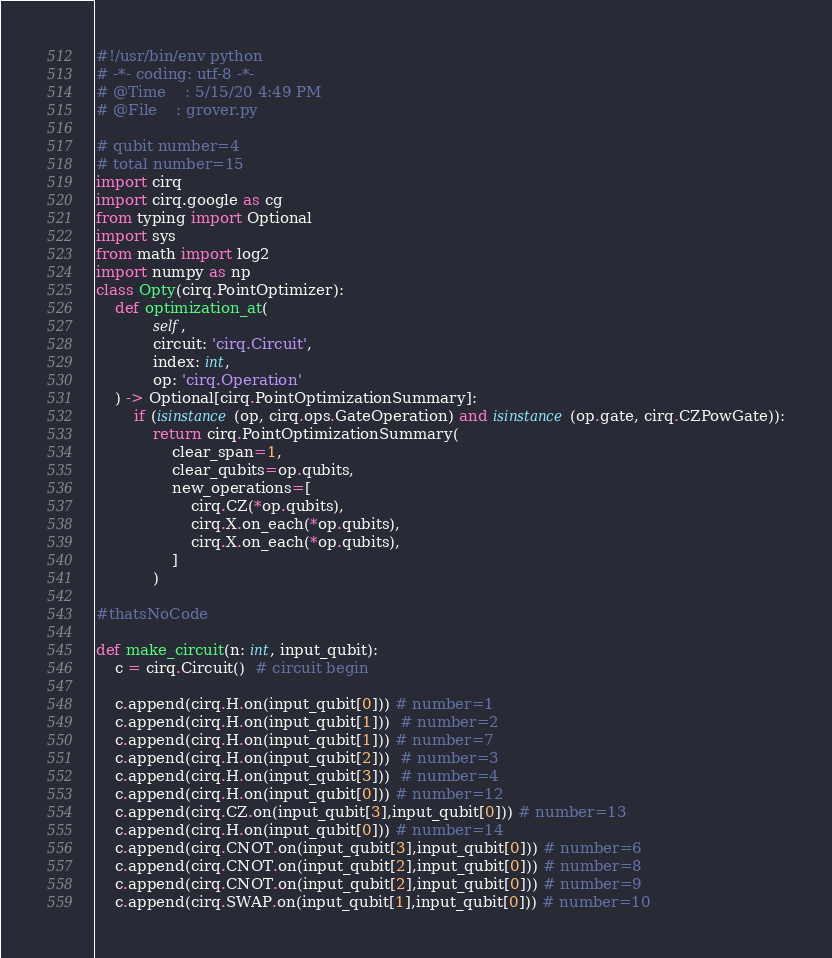Convert code to text. <code><loc_0><loc_0><loc_500><loc_500><_Python_>#!/usr/bin/env python
# -*- coding: utf-8 -*-
# @Time    : 5/15/20 4:49 PM
# @File    : grover.py

# qubit number=4
# total number=15
import cirq
import cirq.google as cg
from typing import Optional
import sys
from math import log2
import numpy as np
class Opty(cirq.PointOptimizer):
    def optimization_at(
            self,
            circuit: 'cirq.Circuit',
            index: int,
            op: 'cirq.Operation'
    ) -> Optional[cirq.PointOptimizationSummary]:
        if (isinstance(op, cirq.ops.GateOperation) and isinstance(op.gate, cirq.CZPowGate)):
            return cirq.PointOptimizationSummary(
                clear_span=1,
                clear_qubits=op.qubits, 
                new_operations=[
                    cirq.CZ(*op.qubits),
                    cirq.X.on_each(*op.qubits),
                    cirq.X.on_each(*op.qubits),
                ]
            )

#thatsNoCode

def make_circuit(n: int, input_qubit):
    c = cirq.Circuit()  # circuit begin

    c.append(cirq.H.on(input_qubit[0])) # number=1
    c.append(cirq.H.on(input_qubit[1]))  # number=2
    c.append(cirq.H.on(input_qubit[1])) # number=7
    c.append(cirq.H.on(input_qubit[2]))  # number=3
    c.append(cirq.H.on(input_qubit[3]))  # number=4
    c.append(cirq.H.on(input_qubit[0])) # number=12
    c.append(cirq.CZ.on(input_qubit[3],input_qubit[0])) # number=13
    c.append(cirq.H.on(input_qubit[0])) # number=14
    c.append(cirq.CNOT.on(input_qubit[3],input_qubit[0])) # number=6
    c.append(cirq.CNOT.on(input_qubit[2],input_qubit[0])) # number=8
    c.append(cirq.CNOT.on(input_qubit[2],input_qubit[0])) # number=9
    c.append(cirq.SWAP.on(input_qubit[1],input_qubit[0])) # number=10</code> 